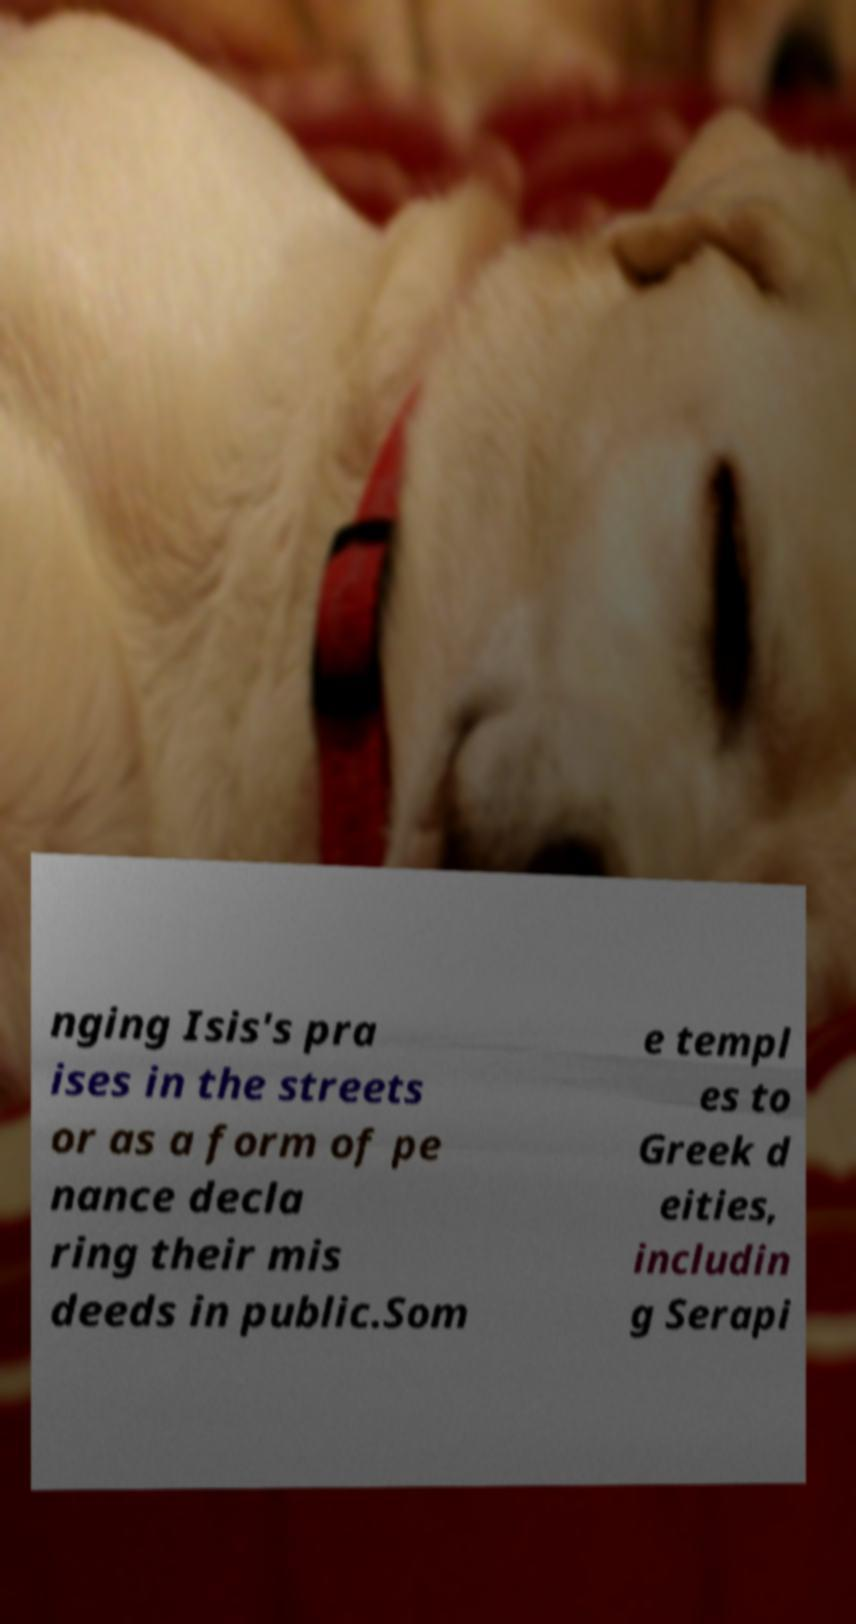Can you read and provide the text displayed in the image?This photo seems to have some interesting text. Can you extract and type it out for me? nging Isis's pra ises in the streets or as a form of pe nance decla ring their mis deeds in public.Som e templ es to Greek d eities, includin g Serapi 